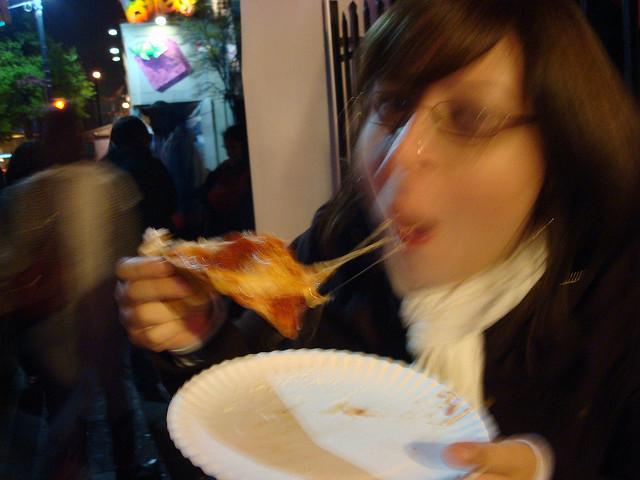Is she eating off of a paper plate?
Short answer required. Yes. What toppings are on the pizza?
Quick response, please. Pepperoni. Is this photo clear?
Write a very short answer. No. 